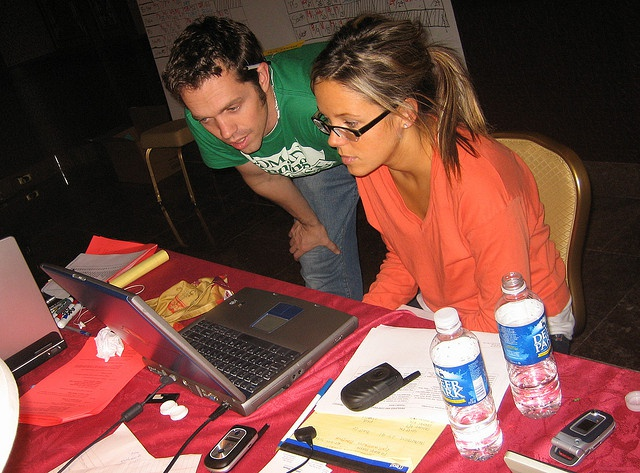Describe the objects in this image and their specific colors. I can see people in black, salmon, red, and brown tones, people in black, gray, brown, and darkgreen tones, laptop in black, maroon, and gray tones, bottle in black, white, lightpink, lightblue, and gray tones, and bottle in black, white, lightpink, brown, and blue tones in this image. 